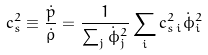<formula> <loc_0><loc_0><loc_500><loc_500>c _ { s } ^ { 2 } \equiv \frac { \dot { p } } { \dot { \rho } } = \frac { 1 } { \sum _ { j } \dot { \phi } _ { j } ^ { 2 } } \sum _ { i } c _ { s \, i } ^ { 2 } \dot { \phi } _ { i } ^ { 2 }</formula> 